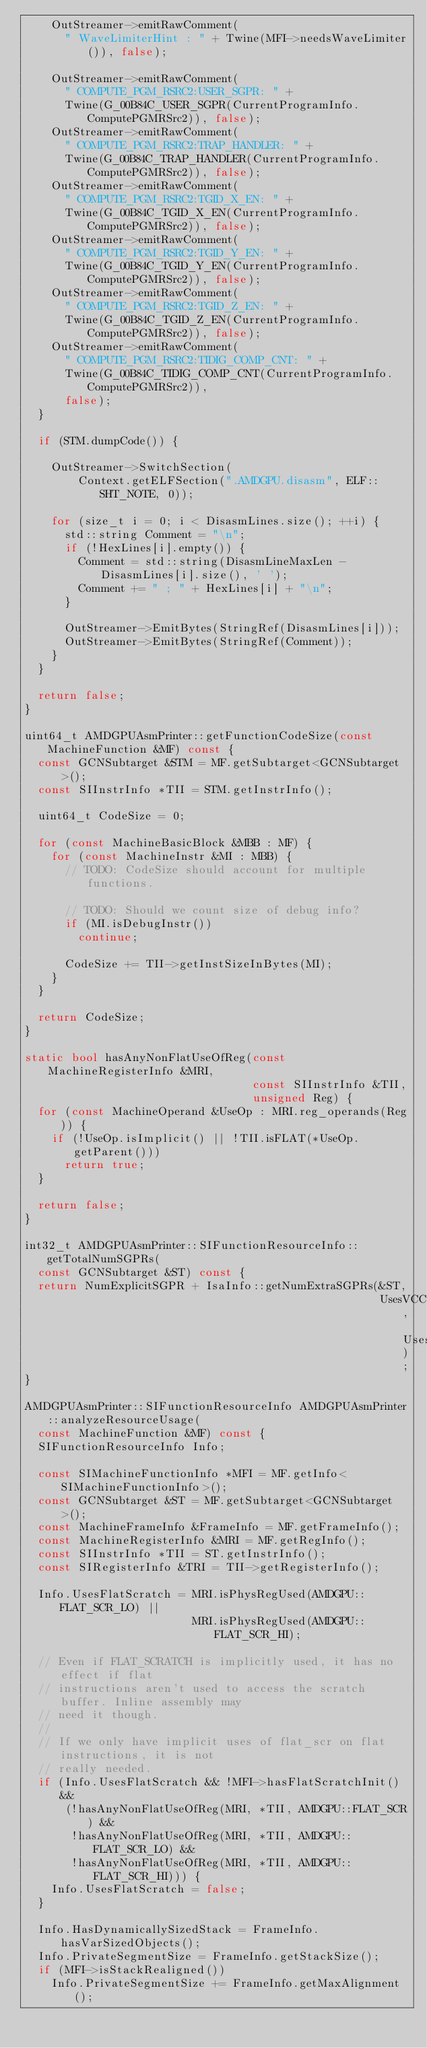Convert code to text. <code><loc_0><loc_0><loc_500><loc_500><_C++_>    OutStreamer->emitRawComment(
      " WaveLimiterHint : " + Twine(MFI->needsWaveLimiter()), false);

    OutStreamer->emitRawComment(
      " COMPUTE_PGM_RSRC2:USER_SGPR: " +
      Twine(G_00B84C_USER_SGPR(CurrentProgramInfo.ComputePGMRSrc2)), false);
    OutStreamer->emitRawComment(
      " COMPUTE_PGM_RSRC2:TRAP_HANDLER: " +
      Twine(G_00B84C_TRAP_HANDLER(CurrentProgramInfo.ComputePGMRSrc2)), false);
    OutStreamer->emitRawComment(
      " COMPUTE_PGM_RSRC2:TGID_X_EN: " +
      Twine(G_00B84C_TGID_X_EN(CurrentProgramInfo.ComputePGMRSrc2)), false);
    OutStreamer->emitRawComment(
      " COMPUTE_PGM_RSRC2:TGID_Y_EN: " +
      Twine(G_00B84C_TGID_Y_EN(CurrentProgramInfo.ComputePGMRSrc2)), false);
    OutStreamer->emitRawComment(
      " COMPUTE_PGM_RSRC2:TGID_Z_EN: " +
      Twine(G_00B84C_TGID_Z_EN(CurrentProgramInfo.ComputePGMRSrc2)), false);
    OutStreamer->emitRawComment(
      " COMPUTE_PGM_RSRC2:TIDIG_COMP_CNT: " +
      Twine(G_00B84C_TIDIG_COMP_CNT(CurrentProgramInfo.ComputePGMRSrc2)),
      false);
  }

  if (STM.dumpCode()) {

    OutStreamer->SwitchSection(
        Context.getELFSection(".AMDGPU.disasm", ELF::SHT_NOTE, 0));

    for (size_t i = 0; i < DisasmLines.size(); ++i) {
      std::string Comment = "\n";
      if (!HexLines[i].empty()) {
        Comment = std::string(DisasmLineMaxLen - DisasmLines[i].size(), ' ');
        Comment += " ; " + HexLines[i] + "\n";
      }

      OutStreamer->EmitBytes(StringRef(DisasmLines[i]));
      OutStreamer->EmitBytes(StringRef(Comment));
    }
  }

  return false;
}

uint64_t AMDGPUAsmPrinter::getFunctionCodeSize(const MachineFunction &MF) const {
  const GCNSubtarget &STM = MF.getSubtarget<GCNSubtarget>();
  const SIInstrInfo *TII = STM.getInstrInfo();

  uint64_t CodeSize = 0;

  for (const MachineBasicBlock &MBB : MF) {
    for (const MachineInstr &MI : MBB) {
      // TODO: CodeSize should account for multiple functions.

      // TODO: Should we count size of debug info?
      if (MI.isDebugInstr())
        continue;

      CodeSize += TII->getInstSizeInBytes(MI);
    }
  }

  return CodeSize;
}

static bool hasAnyNonFlatUseOfReg(const MachineRegisterInfo &MRI,
                                  const SIInstrInfo &TII,
                                  unsigned Reg) {
  for (const MachineOperand &UseOp : MRI.reg_operands(Reg)) {
    if (!UseOp.isImplicit() || !TII.isFLAT(*UseOp.getParent()))
      return true;
  }

  return false;
}

int32_t AMDGPUAsmPrinter::SIFunctionResourceInfo::getTotalNumSGPRs(
  const GCNSubtarget &ST) const {
  return NumExplicitSGPR + IsaInfo::getNumExtraSGPRs(&ST,
                                                     UsesVCC, UsesFlatScratch);
}

AMDGPUAsmPrinter::SIFunctionResourceInfo AMDGPUAsmPrinter::analyzeResourceUsage(
  const MachineFunction &MF) const {
  SIFunctionResourceInfo Info;

  const SIMachineFunctionInfo *MFI = MF.getInfo<SIMachineFunctionInfo>();
  const GCNSubtarget &ST = MF.getSubtarget<GCNSubtarget>();
  const MachineFrameInfo &FrameInfo = MF.getFrameInfo();
  const MachineRegisterInfo &MRI = MF.getRegInfo();
  const SIInstrInfo *TII = ST.getInstrInfo();
  const SIRegisterInfo &TRI = TII->getRegisterInfo();

  Info.UsesFlatScratch = MRI.isPhysRegUsed(AMDGPU::FLAT_SCR_LO) ||
                         MRI.isPhysRegUsed(AMDGPU::FLAT_SCR_HI);

  // Even if FLAT_SCRATCH is implicitly used, it has no effect if flat
  // instructions aren't used to access the scratch buffer. Inline assembly may
  // need it though.
  //
  // If we only have implicit uses of flat_scr on flat instructions, it is not
  // really needed.
  if (Info.UsesFlatScratch && !MFI->hasFlatScratchInit() &&
      (!hasAnyNonFlatUseOfReg(MRI, *TII, AMDGPU::FLAT_SCR) &&
       !hasAnyNonFlatUseOfReg(MRI, *TII, AMDGPU::FLAT_SCR_LO) &&
       !hasAnyNonFlatUseOfReg(MRI, *TII, AMDGPU::FLAT_SCR_HI))) {
    Info.UsesFlatScratch = false;
  }

  Info.HasDynamicallySizedStack = FrameInfo.hasVarSizedObjects();
  Info.PrivateSegmentSize = FrameInfo.getStackSize();
  if (MFI->isStackRealigned())
    Info.PrivateSegmentSize += FrameInfo.getMaxAlignment();

</code> 